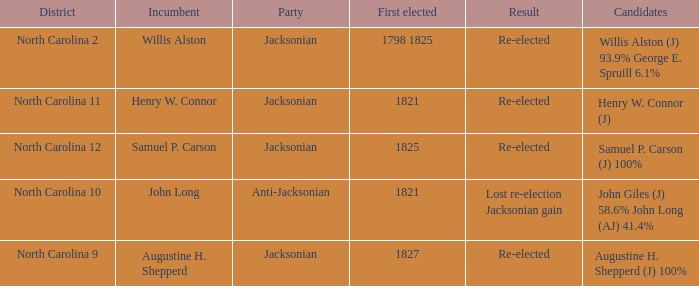State the conclusion for augustine h. shepperd (j) with 100% completion. Re-elected. 